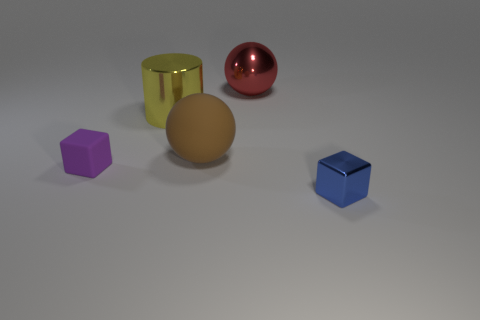Add 3 red metallic cubes. How many objects exist? 8 Subtract 1 spheres. How many spheres are left? 1 Subtract all red balls. How many balls are left? 1 Subtract all spheres. How many objects are left? 3 Subtract all green spheres. Subtract all green cylinders. How many spheres are left? 2 Subtract all small blue objects. Subtract all tiny metal objects. How many objects are left? 3 Add 1 brown things. How many brown things are left? 2 Add 2 brown objects. How many brown objects exist? 3 Subtract 0 brown blocks. How many objects are left? 5 